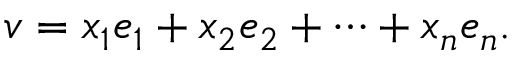<formula> <loc_0><loc_0><loc_500><loc_500>v = x _ { 1 } e _ { 1 } + x _ { 2 } e _ { 2 } + \dots b + x _ { n } e _ { n } .</formula> 